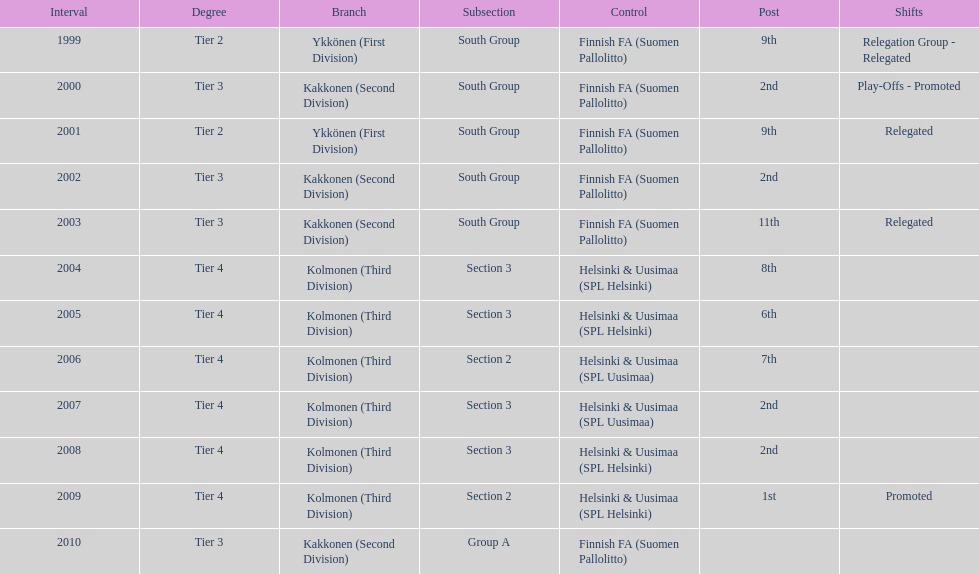When was the last year they placed 2nd? 2008. 